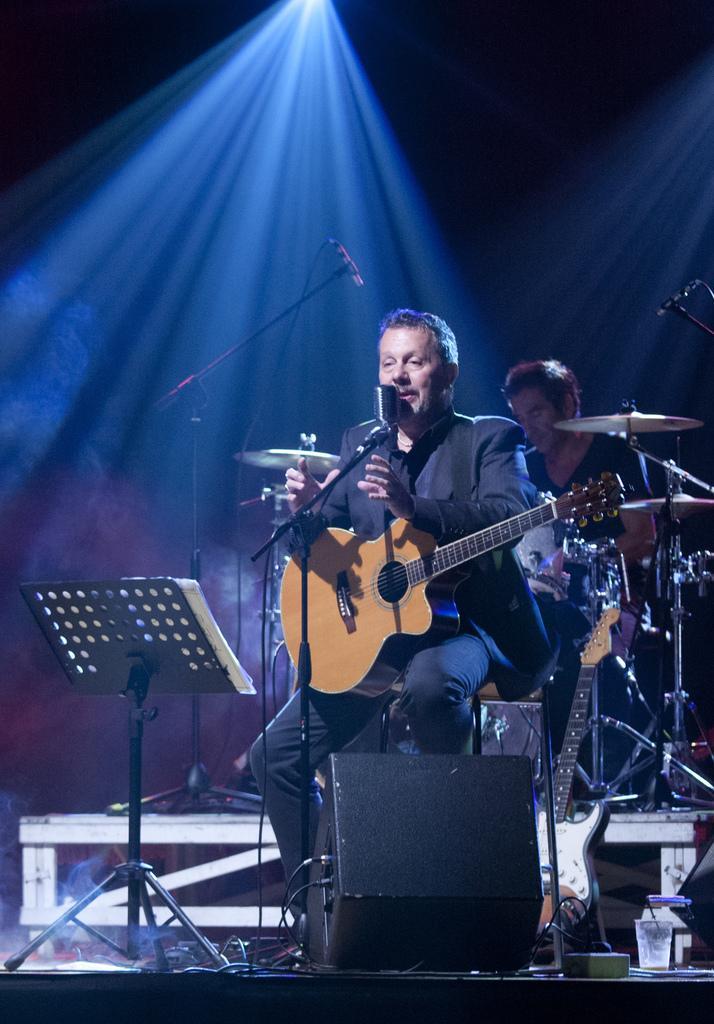Please provide a concise description of this image. The picture is taken on a stage in which one man is sitting in a black dress and holding a guitar and singing in the microphone, behind him there is one person playing drums, in front of the man there is one paper stand on which papers are placed and a speaker and a there is a bench present in the picture. 